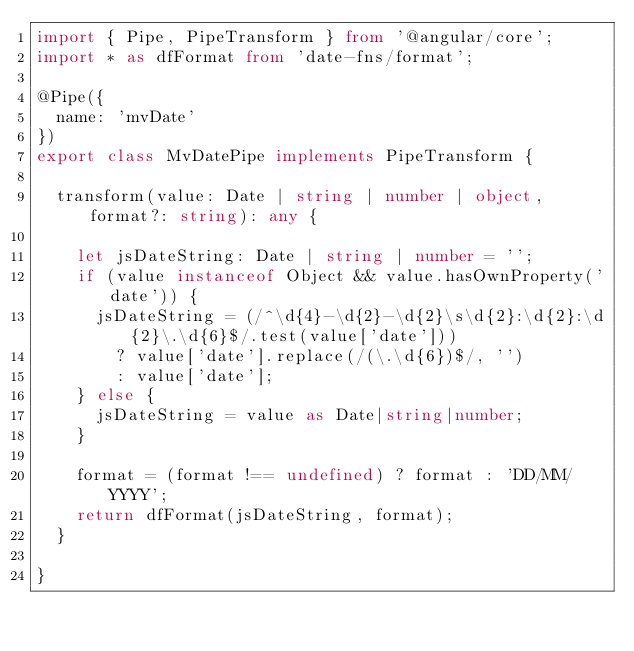Convert code to text. <code><loc_0><loc_0><loc_500><loc_500><_TypeScript_>import { Pipe, PipeTransform } from '@angular/core';
import * as dfFormat from 'date-fns/format';

@Pipe({
  name: 'mvDate'
})
export class MvDatePipe implements PipeTransform {

  transform(value: Date | string | number | object, format?: string): any {

    let jsDateString: Date | string | number = '';
    if (value instanceof Object && value.hasOwnProperty('date')) {
      jsDateString = (/^\d{4}-\d{2}-\d{2}\s\d{2}:\d{2}:\d{2}\.\d{6}$/.test(value['date']))
        ? value['date'].replace(/(\.\d{6})$/, '')
        : value['date'];
    } else {
      jsDateString = value as Date|string|number;
    }

    format = (format !== undefined) ? format : 'DD/MM/YYYY';
    return dfFormat(jsDateString, format);
  }

}
</code> 